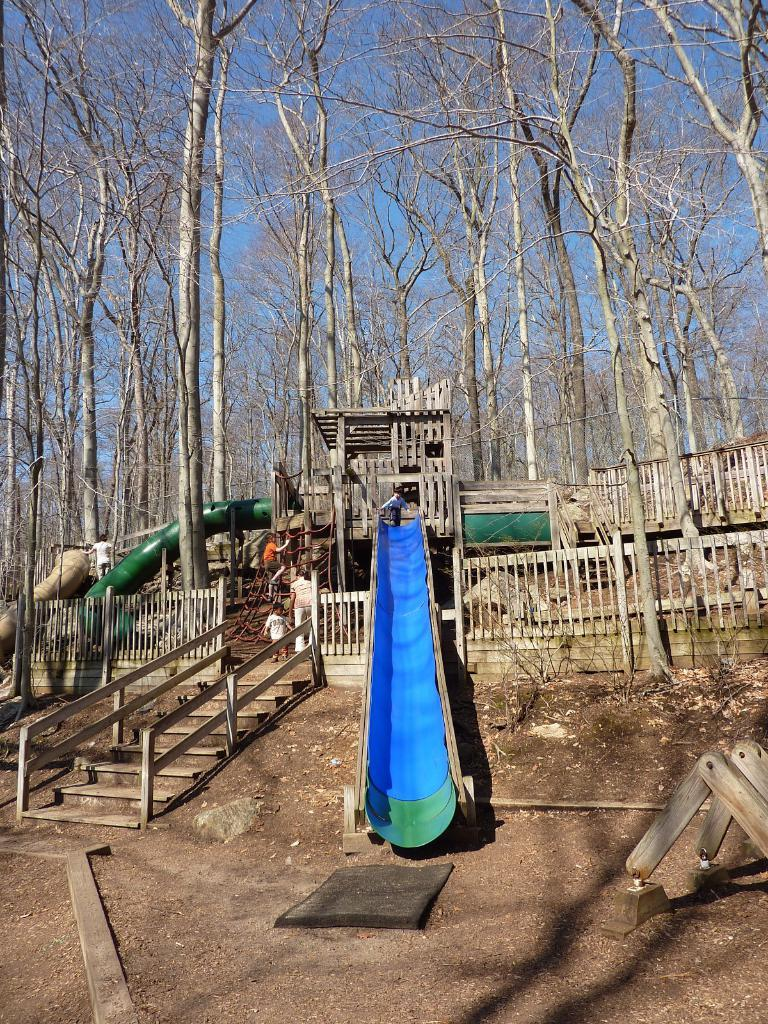What type of vegetation can be seen in the image? There are trees in the image. What part of the natural environment is visible in the image? The sky is visible in the image. What type of structure is present in the image? There is a wooden house in the image. What type of barrier is present in the image? Wooden fences are present in the image. What architectural feature is visible in the image? There is a staircase in the image. What safety feature is visible in the image? Railings are visible in the image. Who is present in the image? Children are present in the image. What type of playground equipment is visible in the image? There is a slide in the image. What type of jelly is being used to construct the wooden house in the image? There is no jelly present in the image, and the wooden house is not constructed using jelly. How does the love between the children manifest in the image? The image does not depict any emotions or relationships between the children, so it is not possible to determine how love might manifest in the image. 